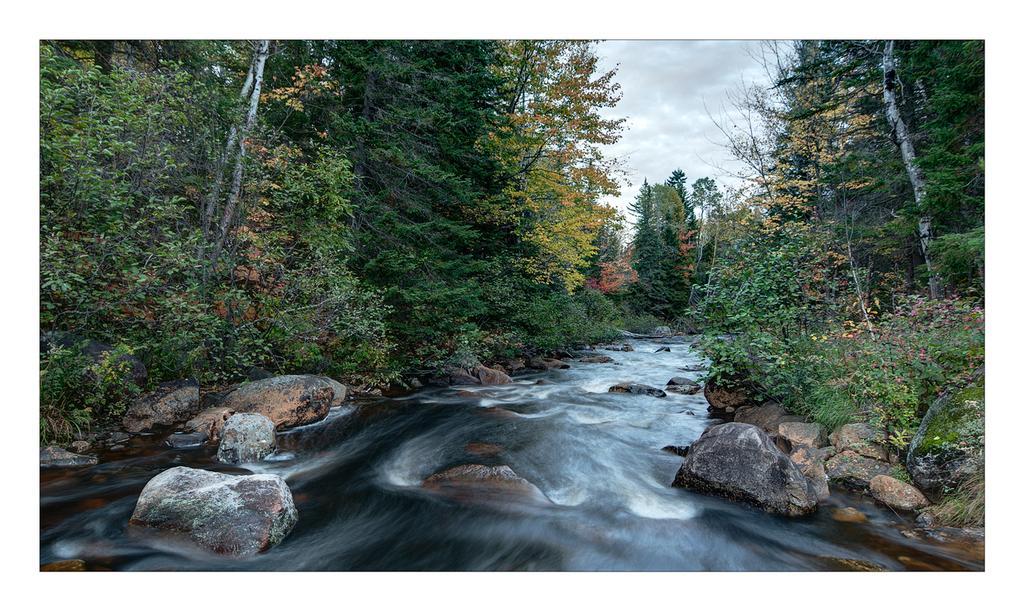Can you describe this image briefly? In this image I can see the water, few rocks and few trees on both sides of the water which are green, yellow and orange in color. In the background I can see the sky. 